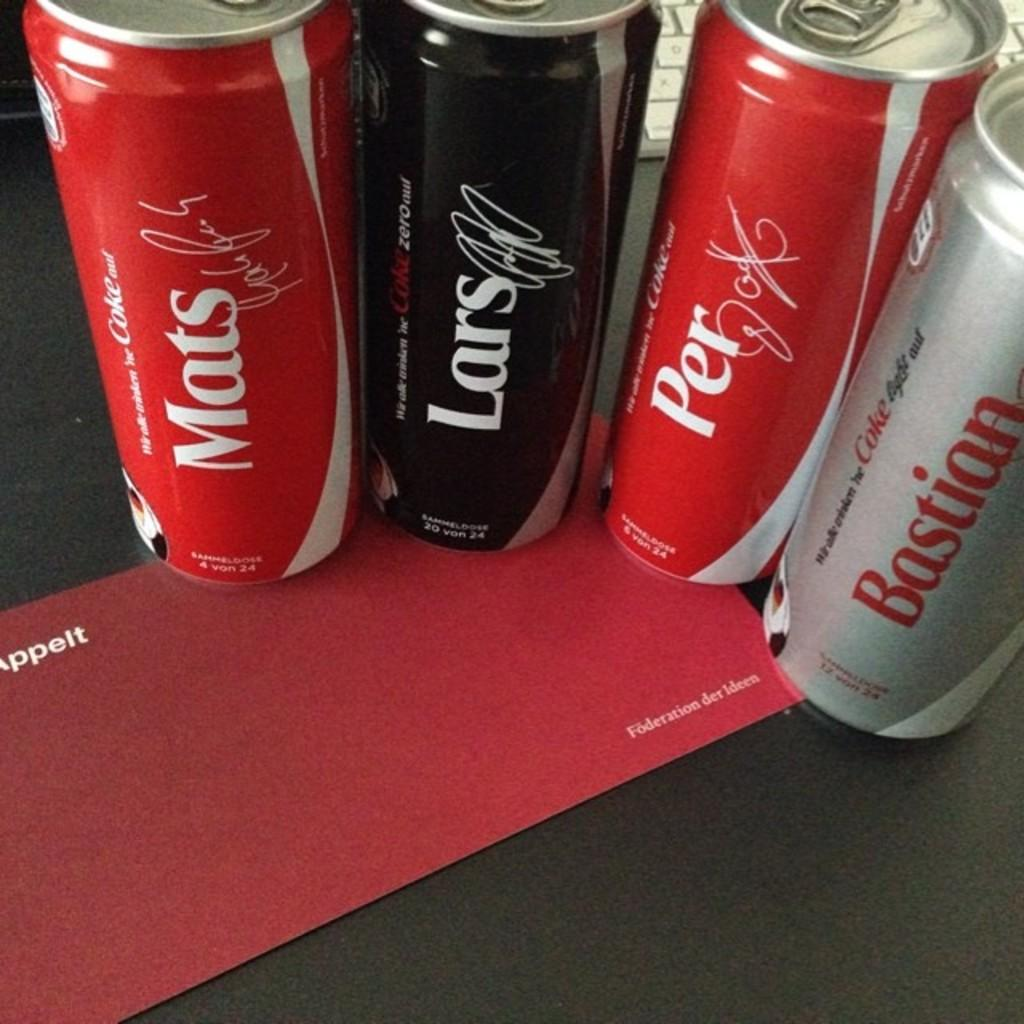Provide a one-sentence caption for the provided image. Four different Coke cans on a row with one saying Bastian. 